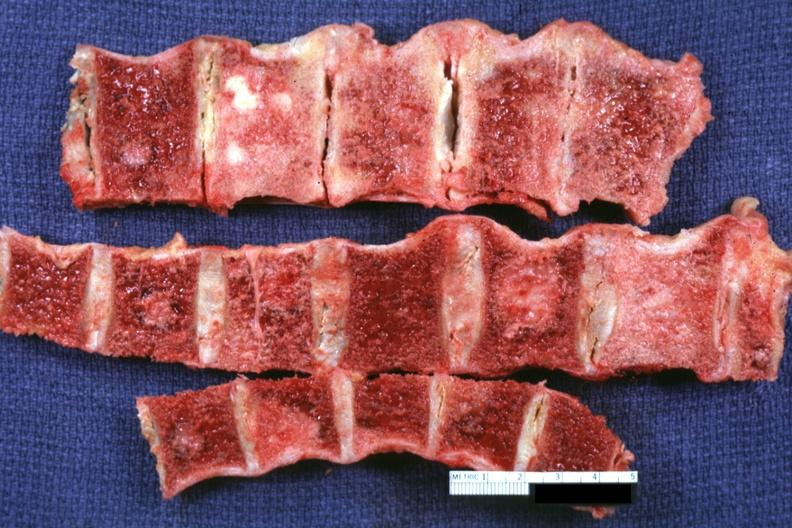what does this image show?
Answer the question using a single word or phrase. Several segments of vertebral column with easily seen metastatic lesions primary prostate adenocarcinoma 